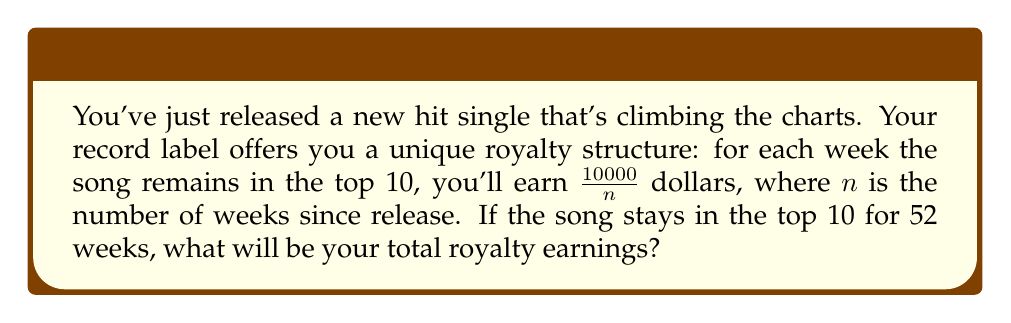Could you help me with this problem? To solve this problem, we need to use the concept of a harmonic series. The earnings for each week form a harmonic sequence:

Week 1: $\frac{10000}{1}$
Week 2: $\frac{10000}{2}$
Week 3: $\frac{10000}{3}$
...
Week 52: $\frac{10000}{52}$

The total earnings will be the sum of this series:

$$S = 10000 \cdot \sum_{n=1}^{52} \frac{1}{n}$$

This is a partial sum of the harmonic series. There's no simple closed form for this sum, but we can approximate it using the formula:

$$\sum_{n=1}^{N} \frac{1}{n} \approx \ln(N) + \gamma$$

Where $\gamma$ is the Euler-Mascheroni constant, approximately 0.5772156649.

Plugging in our values:

$$S \approx 10000 \cdot (\ln(52) + 0.5772156649)$$
$$S \approx 10000 \cdot (3.9512437186 + 0.5772156649)$$
$$S \approx 10000 \cdot 4.5284593835$$
$$S \approx 45284.59$$

Rounding to the nearest dollar, the total earnings would be $45,285.
Answer: $45,285 